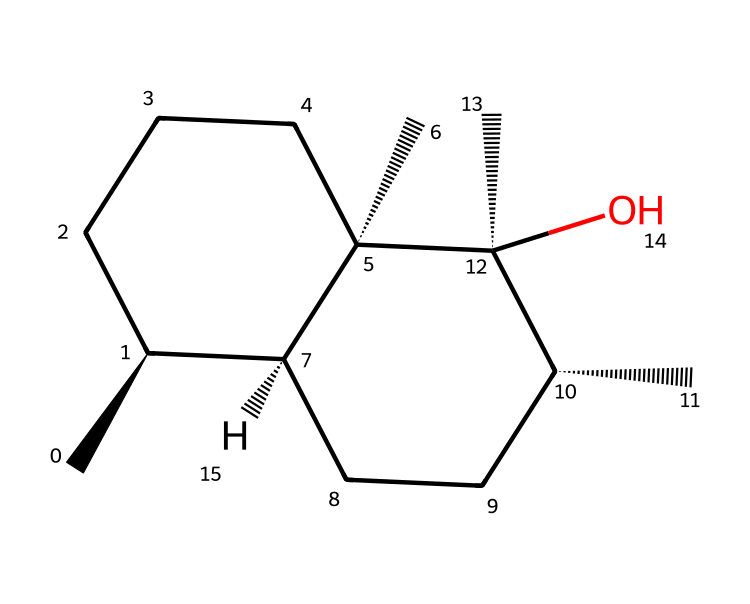how many carbon atoms are present in the structure? The SMILES representation indicates the presence of multiple carbon atoms. By counting the 'C' symbols, including those in the branches, we find there are a total of 10 carbon atoms.
Answer: 10 what type of functional group is visible in geosmin? The 'O' in the SMILES representation indicates the presence of a hydroxyl (-OH) group, which is a functional group that characterizes geosmin as an alcohol.
Answer: alcohol how many stereocenters are present in geosmin? The '@' symbols indicate chiral centers in the structure. By examining the SMILES, there are four '@' symbols, which indicates there are four stereocenters in geosmin.
Answer: 4 what is the molecular classification of geosmin? Geosmin is classified as a terpenoid because its structure derives from isoprene units, and it has a characteristic earthy aroma.
Answer: terpenoid what is the molecular formula for geosmin? To derive the molecular formula, we combine the counts of each atom present in the geosmin structure: 10 carbons (C), 18 hydrogens (H), and 1 oxygen (O), leading to the formula C10H18O.
Answer: C10H18O 